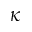Convert formula to latex. <formula><loc_0><loc_0><loc_500><loc_500>\kappa</formula> 